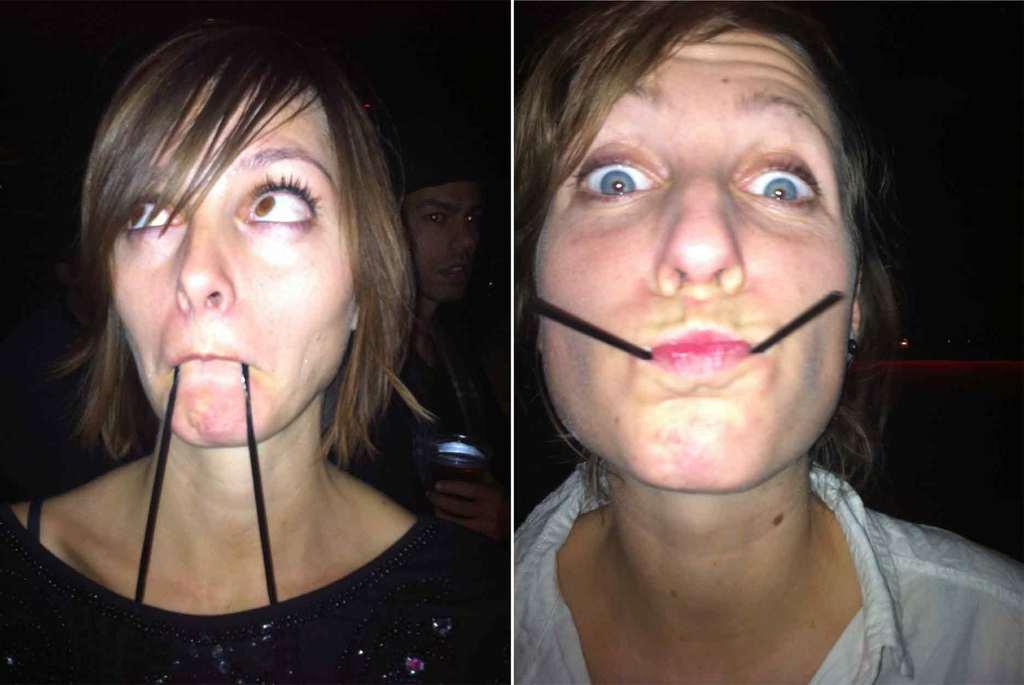What type of images are present in the collage in the image? There are collage photos of people in the image. Can you describe the overall lighting condition of the image? The image is a little bit dark. What type of apparatus is being used to take the photos in the image? There is no apparatus visible in the image, as it only features the collage of photos. Can you see the camera used to capture the photos in the image? There is no camera present in the image, as it only features the collage of photos. 